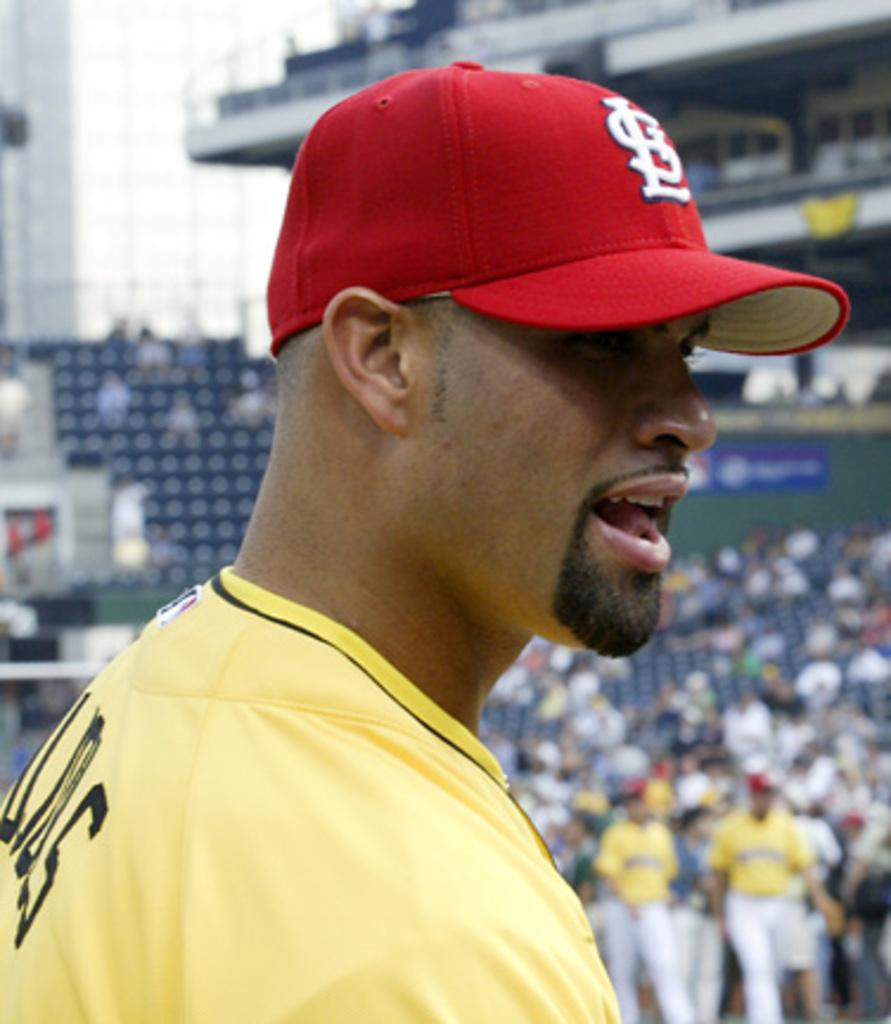<image>
Provide a brief description of the given image. A man in a yellow shirt and red LS hat. 